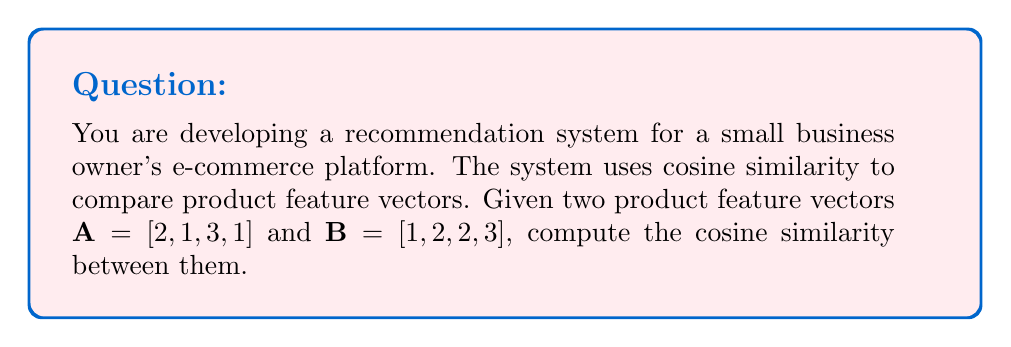Help me with this question. To compute the cosine similarity between two vectors, we use the formula:

$$\text{cosine similarity} = \frac{A \cdot B}{\|A\| \|B\|}$$

Where $A \cdot B$ is the dot product of vectors $A$ and $B$, and $\|A\|$ and $\|B\|$ are the magnitudes (Euclidean norms) of vectors $A$ and $B$ respectively.

Step 1: Calculate the dot product $A \cdot B$
$$A \cdot B = (2 \times 1) + (1 \times 2) + (3 \times 2) + (1 \times 3) = 2 + 2 + 6 + 3 = 13$$

Step 2: Calculate the magnitude of vector $A$
$$\|A\| = \sqrt{2^2 + 1^2 + 3^2 + 1^2} = \sqrt{4 + 1 + 9 + 1} = \sqrt{15}$$

Step 3: Calculate the magnitude of vector $B$
$$\|B\| = \sqrt{1^2 + 2^2 + 2^2 + 3^2} = \sqrt{1 + 4 + 4 + 9} = \sqrt{18}$$

Step 4: Apply the cosine similarity formula
$$\text{cosine similarity} = \frac{13}{\sqrt{15} \times \sqrt{18}} = \frac{13}{\sqrt{270}}$$

Step 5: Simplify the final result
$$\text{cosine similarity} = \frac{13}{\sqrt{270}} \approx 0.7919$$
Answer: The cosine similarity between vectors $A$ and $B$ is $\frac{13}{\sqrt{270}} \approx 0.7919$. 